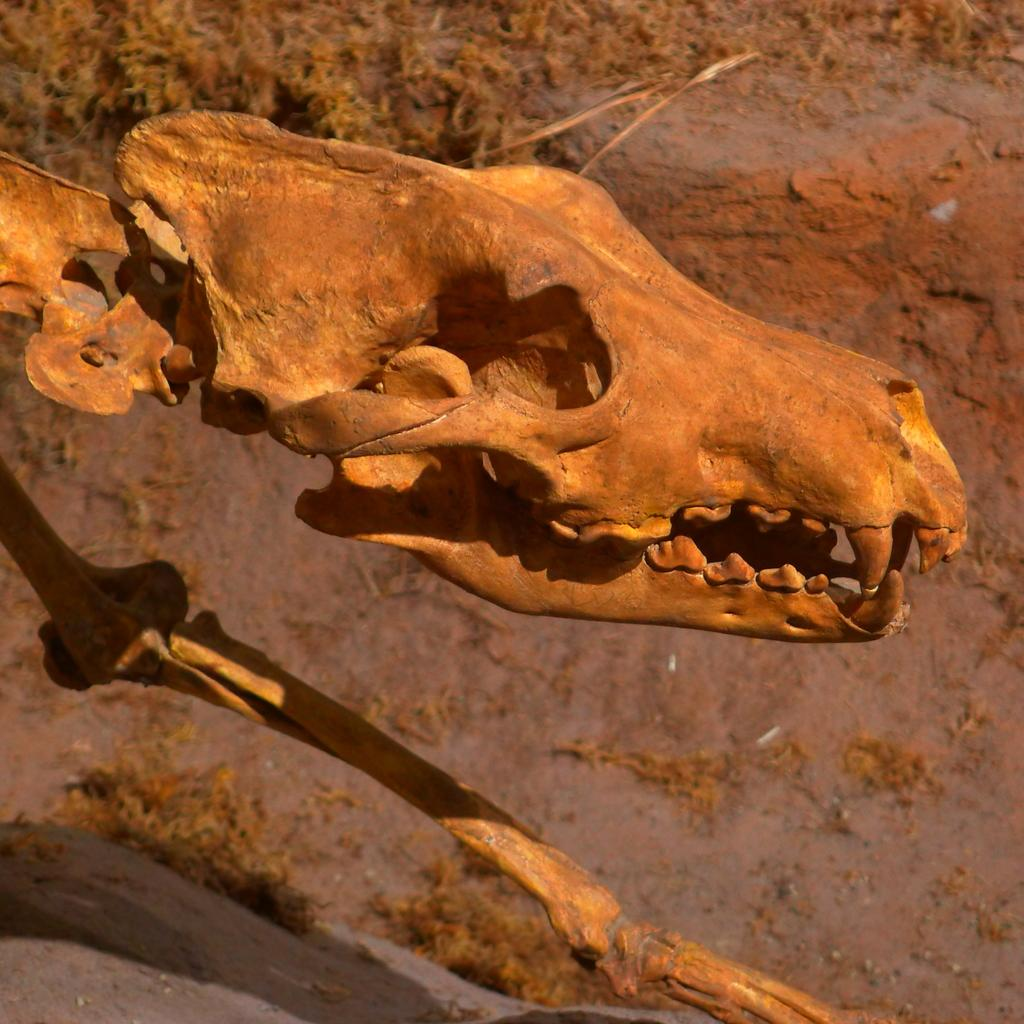What is the main subject of the image? There is an animal skeleton in the image. What can be seen in the background of the image? There are plants and mud visible in the background of the image. Where is the desk located in the image? There is no desk present in the image. What type of icicle can be seen hanging from the animal skeleton in the image? There are no icicles present in the image; it features an animal skeleton and plants in the background. 